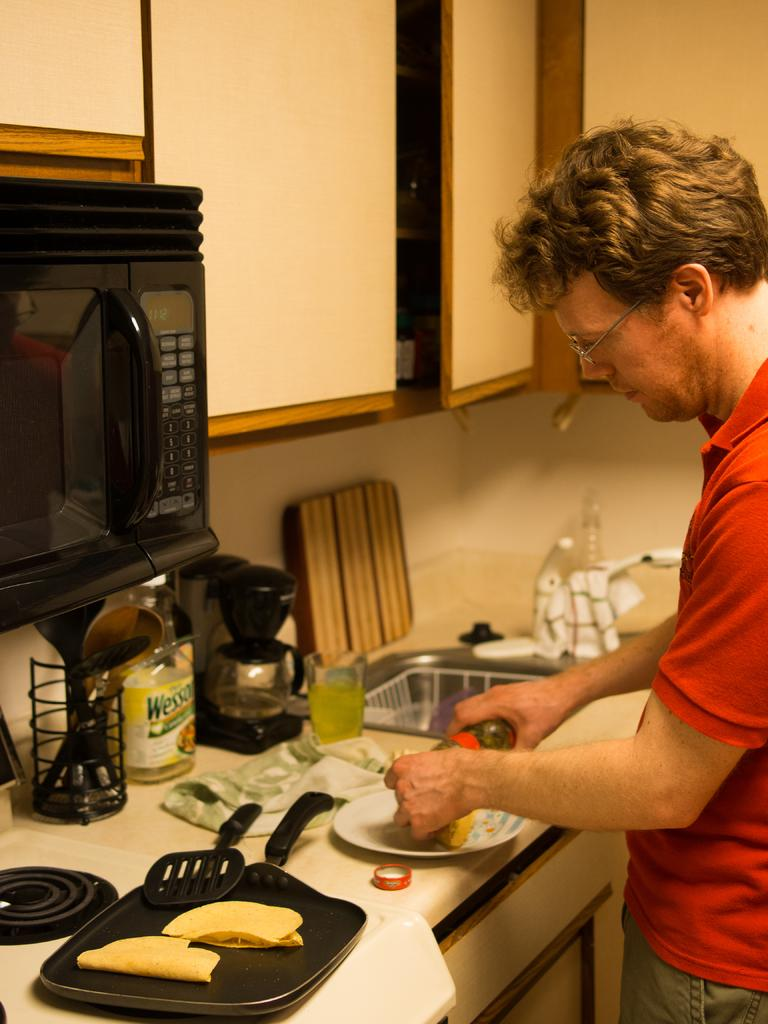What type of furniture is present in the image? There is a cupboard in the image. What utensil can be seen in the image? There is a spoon in the image. What is used for serving food in the image? There is a plate in the image. What else can be seen in the image besides the mentioned objects? There are other objects in the image. Who is present in the image? There is a person on the right side of the image. What type of railway can be seen in the image? There is no railway present in the image. 